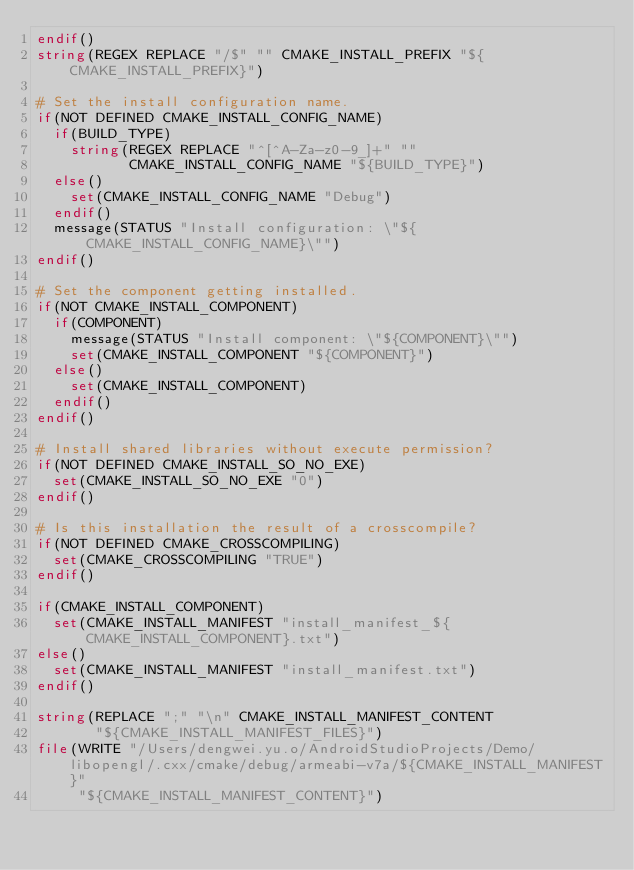<code> <loc_0><loc_0><loc_500><loc_500><_CMake_>endif()
string(REGEX REPLACE "/$" "" CMAKE_INSTALL_PREFIX "${CMAKE_INSTALL_PREFIX}")

# Set the install configuration name.
if(NOT DEFINED CMAKE_INSTALL_CONFIG_NAME)
  if(BUILD_TYPE)
    string(REGEX REPLACE "^[^A-Za-z0-9_]+" ""
           CMAKE_INSTALL_CONFIG_NAME "${BUILD_TYPE}")
  else()
    set(CMAKE_INSTALL_CONFIG_NAME "Debug")
  endif()
  message(STATUS "Install configuration: \"${CMAKE_INSTALL_CONFIG_NAME}\"")
endif()

# Set the component getting installed.
if(NOT CMAKE_INSTALL_COMPONENT)
  if(COMPONENT)
    message(STATUS "Install component: \"${COMPONENT}\"")
    set(CMAKE_INSTALL_COMPONENT "${COMPONENT}")
  else()
    set(CMAKE_INSTALL_COMPONENT)
  endif()
endif()

# Install shared libraries without execute permission?
if(NOT DEFINED CMAKE_INSTALL_SO_NO_EXE)
  set(CMAKE_INSTALL_SO_NO_EXE "0")
endif()

# Is this installation the result of a crosscompile?
if(NOT DEFINED CMAKE_CROSSCOMPILING)
  set(CMAKE_CROSSCOMPILING "TRUE")
endif()

if(CMAKE_INSTALL_COMPONENT)
  set(CMAKE_INSTALL_MANIFEST "install_manifest_${CMAKE_INSTALL_COMPONENT}.txt")
else()
  set(CMAKE_INSTALL_MANIFEST "install_manifest.txt")
endif()

string(REPLACE ";" "\n" CMAKE_INSTALL_MANIFEST_CONTENT
       "${CMAKE_INSTALL_MANIFEST_FILES}")
file(WRITE "/Users/dengwei.yu.o/AndroidStudioProjects/Demo/libopengl/.cxx/cmake/debug/armeabi-v7a/${CMAKE_INSTALL_MANIFEST}"
     "${CMAKE_INSTALL_MANIFEST_CONTENT}")
</code> 